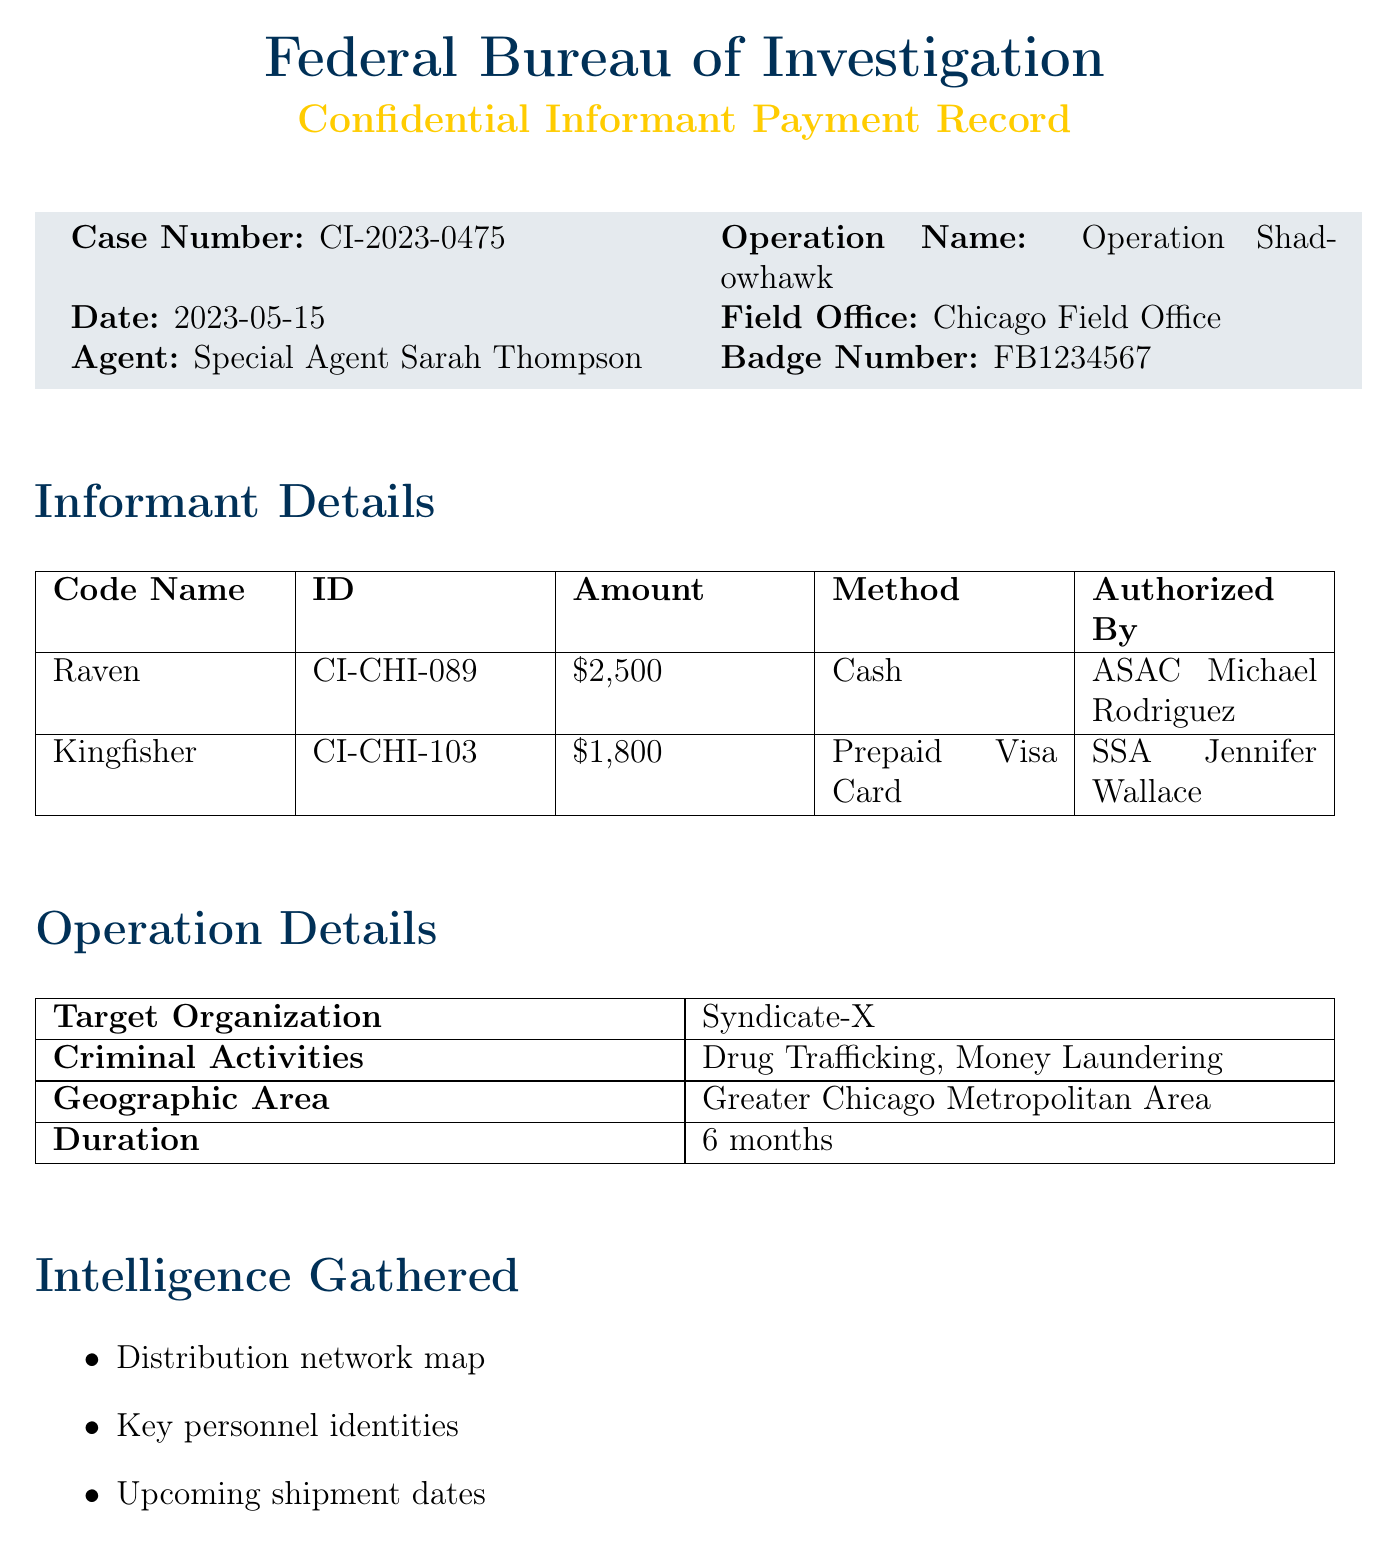What is the case number? The case number is a unique identifier for the investigation detailed in the document.
Answer: CI-2023-0475 Who is the approving official? The approving official is the person who authorized the payments, listed in the document.
Answer: SAC David Chen What is the payment amount for the informant "Raven"? The payment amount is specified next to each informant, showcasing how much they were compensated.
Answer: $2,500 What is the total payout? The total payout calculated from the payments made to informants and expenses.
Answer: $4,850 What is the name of the operation? The operation name is used to identify the specific investigation tied to the payments made.
Answer: Operation Shadowhawk Which payment method was used for "Kingfisher"? The payment method is indicated next to each informant's payment details.
Answer: Prepaid Visa Card How long is the duration of the operation? The duration refers to the total length of time the operation is expected to last, as mentioned in the document.
Answer: 6 months What is one of the criminal activities listed in the document? Criminal activities detail the illicit behaviors being investigated and are listed in one section of the document.
Answer: Drug Trafficking What type of expenses are mentioned? The types of expenses provide insights into the operational costs incurred during the investigation.
Answer: Travel, Equipment 